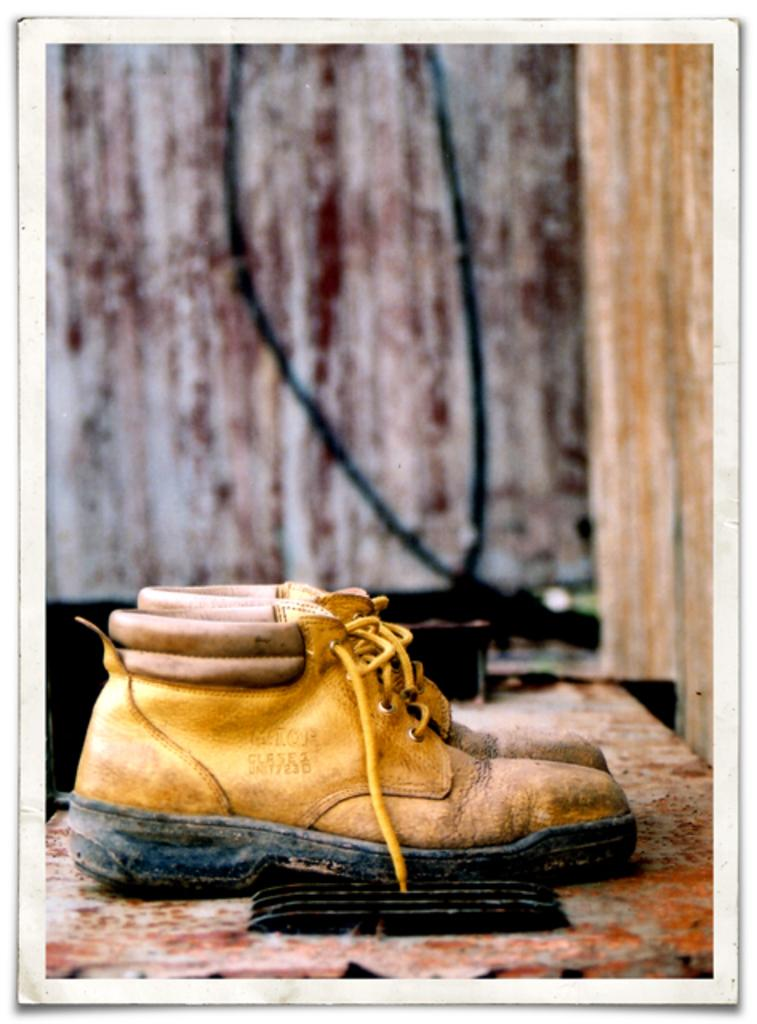What type of object is in the image? There is a pair of shoes in the image. Where are the shoes placed? The shoes are kept on a surface. Can you describe the background of the image? The background of the image is blurred. What type of channel can be seen in the image? There is no channel present in the image; it features a pair of shoes on a surface with a blurred background. Is there a goat in the image? No, there is no goat present in the image. 